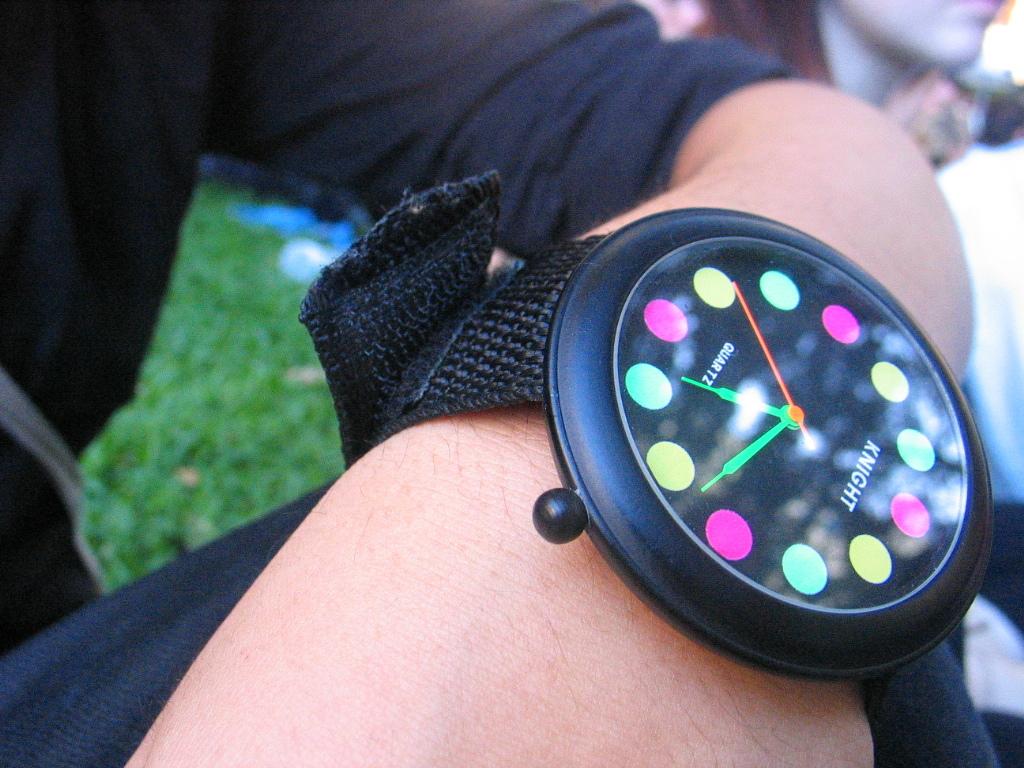What is the name of this watch, shown at the top of it?
Make the answer very short. Knight. What is the word above the pink dot in the 6 o'clock position on the watch?
Your response must be concise. Quartz. 